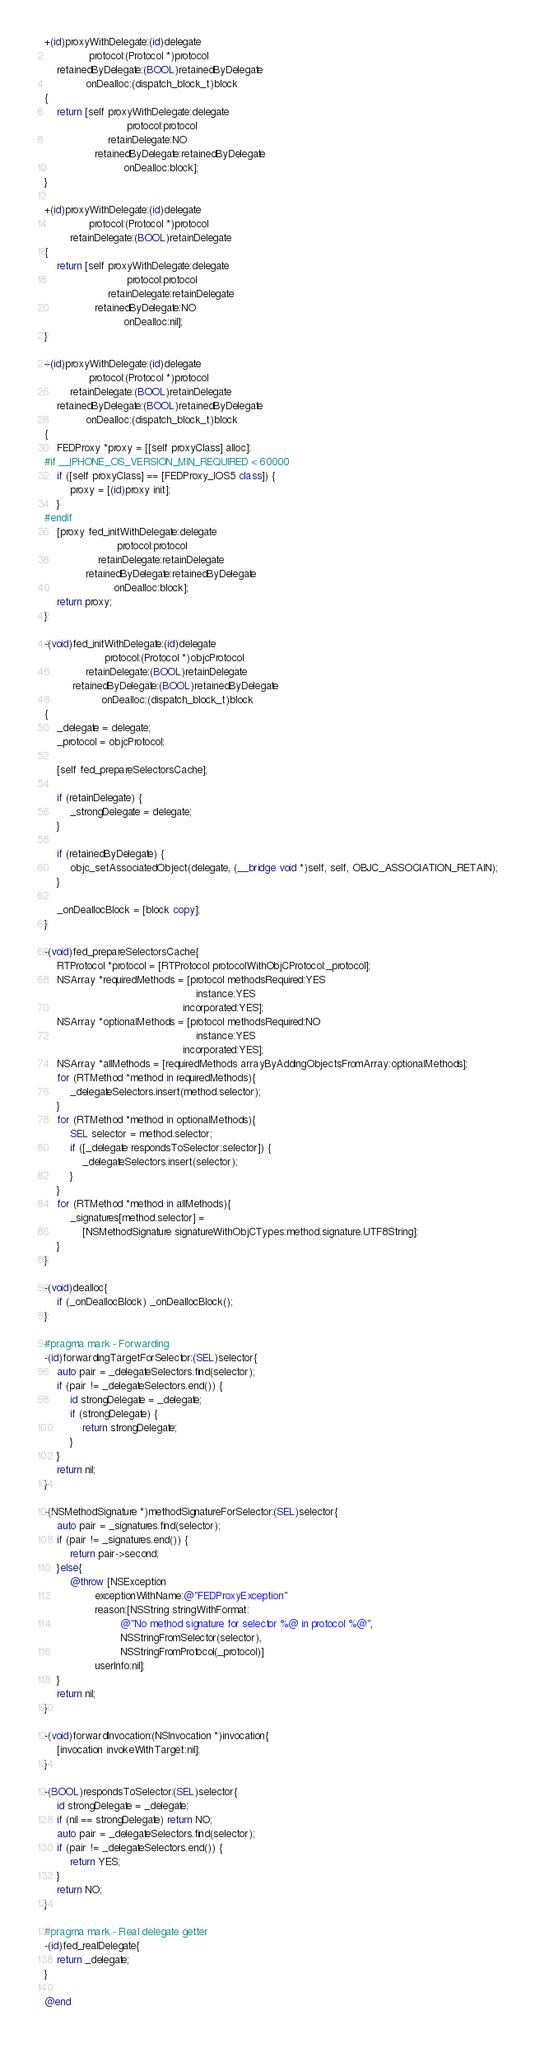<code> <loc_0><loc_0><loc_500><loc_500><_ObjectiveC_>+(id)proxyWithDelegate:(id)delegate
              protocol:(Protocol *)protocol
    retainedByDelegate:(BOOL)retainedByDelegate
             onDealloc:(dispatch_block_t)block
{
    return [self proxyWithDelegate:delegate
                          protocol:protocol
                    retainDelegate:NO
                retainedByDelegate:retainedByDelegate
                         onDealloc:block];
}

+(id)proxyWithDelegate:(id)delegate
              protocol:(Protocol *)protocol
        retainDelegate:(BOOL)retainDelegate
{
    return [self proxyWithDelegate:delegate
                          protocol:protocol
                    retainDelegate:retainDelegate
                retainedByDelegate:NO
                         onDealloc:nil];
}

+(id)proxyWithDelegate:(id)delegate
              protocol:(Protocol *)protocol
        retainDelegate:(BOOL)retainDelegate
    retainedByDelegate:(BOOL)retainedByDelegate
             onDealloc:(dispatch_block_t)block
{
    FEDProxy *proxy = [[self proxyClass] alloc];
#if __IPHONE_OS_VERSION_MIN_REQUIRED < 60000
    if ([self proxyClass] == [FEDProxy_IOS5 class]) {
        proxy = [(id)proxy init];
    }
#endif
    [proxy fed_initWithDelegate:delegate
                       protocol:protocol
                 retainDelegate:retainDelegate
             retainedByDelegate:retainedByDelegate
                      onDealloc:block];
    return proxy;
}

-(void)fed_initWithDelegate:(id)delegate
                   protocol:(Protocol *)objcProtocol
             retainDelegate:(BOOL)retainDelegate
         retainedByDelegate:(BOOL)retainedByDelegate
                  onDealloc:(dispatch_block_t)block
{
    _delegate = delegate;
    _protocol = objcProtocol;
    
    [self fed_prepareSelectorsCache];
    
    if (retainDelegate) {
        _strongDelegate = delegate;
    }
    
    if (retainedByDelegate) {
        objc_setAssociatedObject(delegate, (__bridge void *)self, self, OBJC_ASSOCIATION_RETAIN);
    }
    
    _onDeallocBlock = [block copy];
}

-(void)fed_prepareSelectorsCache{
    RTProtocol *protocol = [RTProtocol protocolWithObjCProtocol:_protocol];
    NSArray *requiredMethods = [protocol methodsRequired:YES
                                                instance:YES
                                            incorporated:YES];
    NSArray *optionalMethods = [protocol methodsRequired:NO
                                                instance:YES
                                            incorporated:YES];
    NSArray *allMethods = [requiredMethods arrayByAddingObjectsFromArray:optionalMethods];
    for (RTMethod *method in requiredMethods){
        _delegateSelectors.insert(method.selector);
    }
    for (RTMethod *method in optionalMethods){
        SEL selector = method.selector;
        if ([_delegate respondsToSelector:selector]) {
            _delegateSelectors.insert(selector);
        }
    }
    for (RTMethod *method in allMethods){
        _signatures[method.selector] =
            [NSMethodSignature signatureWithObjCTypes:method.signature.UTF8String];
    }
}

-(void)dealloc{
    if (_onDeallocBlock) _onDeallocBlock();
}

#pragma mark - Forwarding
-(id)forwardingTargetForSelector:(SEL)selector{
    auto pair = _delegateSelectors.find(selector);
    if (pair != _delegateSelectors.end()) {
        id strongDelegate = _delegate;
        if (strongDelegate) {
            return strongDelegate;
        }
    }
    return nil;
}

-(NSMethodSignature *)methodSignatureForSelector:(SEL)selector{
    auto pair = _signatures.find(selector);
    if (pair != _signatures.end()) {
        return pair->second;
    }else{
        @throw [NSException
                exceptionWithName:@"FEDProxyException"
                reason:[NSString stringWithFormat:
                        @"No method signature for selector %@ in protocol %@",
                        NSStringFromSelector(selector),
                        NSStringFromProtocol(_protocol)]
                userInfo:nil];
    }
    return nil;
}

-(void)forwardInvocation:(NSInvocation *)invocation{
    [invocation invokeWithTarget:nil];
}

-(BOOL)respondsToSelector:(SEL)selector{
    id strongDelegate = _delegate;
    if (nil == strongDelegate) return NO;
    auto pair = _delegateSelectors.find(selector);
    if (pair != _delegateSelectors.end()) {
        return YES;
    }
    return NO;
}

#pragma mark - Real delegate getter
-(id)fed_realDelegate{
    return _delegate;
}

@end
</code> 